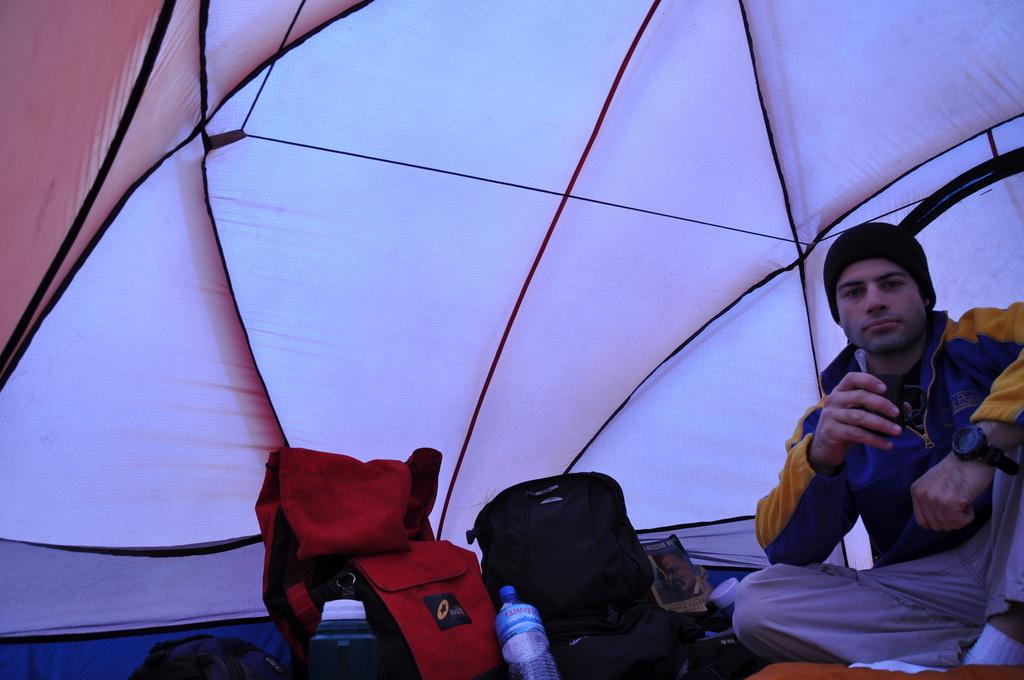What type of space is shown in the image? The image shows an inside view of a tent. Can you describe the person in the image? There is a man sitting on the right side of the tent. What items can be seen in the image besides the man? There are bags, a bottle, and a book visible in the image. What is the man holding in the image? The man is holding a cup. What type of legal advice is the man providing in the image? There is no indication in the image that the man is a lawyer or providing legal advice. 